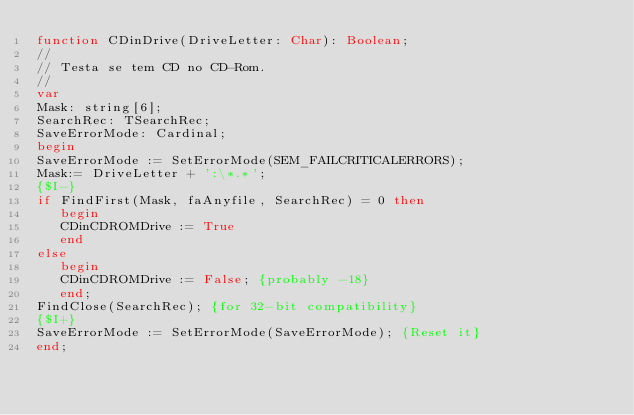<code> <loc_0><loc_0><loc_500><loc_500><_Pascal_>function CDinDrive(DriveLetter: Char): Boolean;
//
// Testa se tem CD no CD-Rom.
//
var
Mask: string[6];
SearchRec: TSearchRec;
SaveErrorMode: Cardinal;
begin
SaveErrorMode := SetErrorMode(SEM_FAILCRITICALERRORS);
Mask:= DriveLetter + ':\*.*';
{$I-}
if FindFirst(Mask, faAnyfile, SearchRec) = 0 then
   begin
   CDinCDROMDrive := True
   end
else
   begin
   CDinCDROMDrive := False; {probably -18}
   end;
FindClose(SearchRec); {for 32-bit compatibility}
{$I+}
SaveErrorMode := SetErrorMode(SaveErrorMode); {Reset it}
end;




</code> 